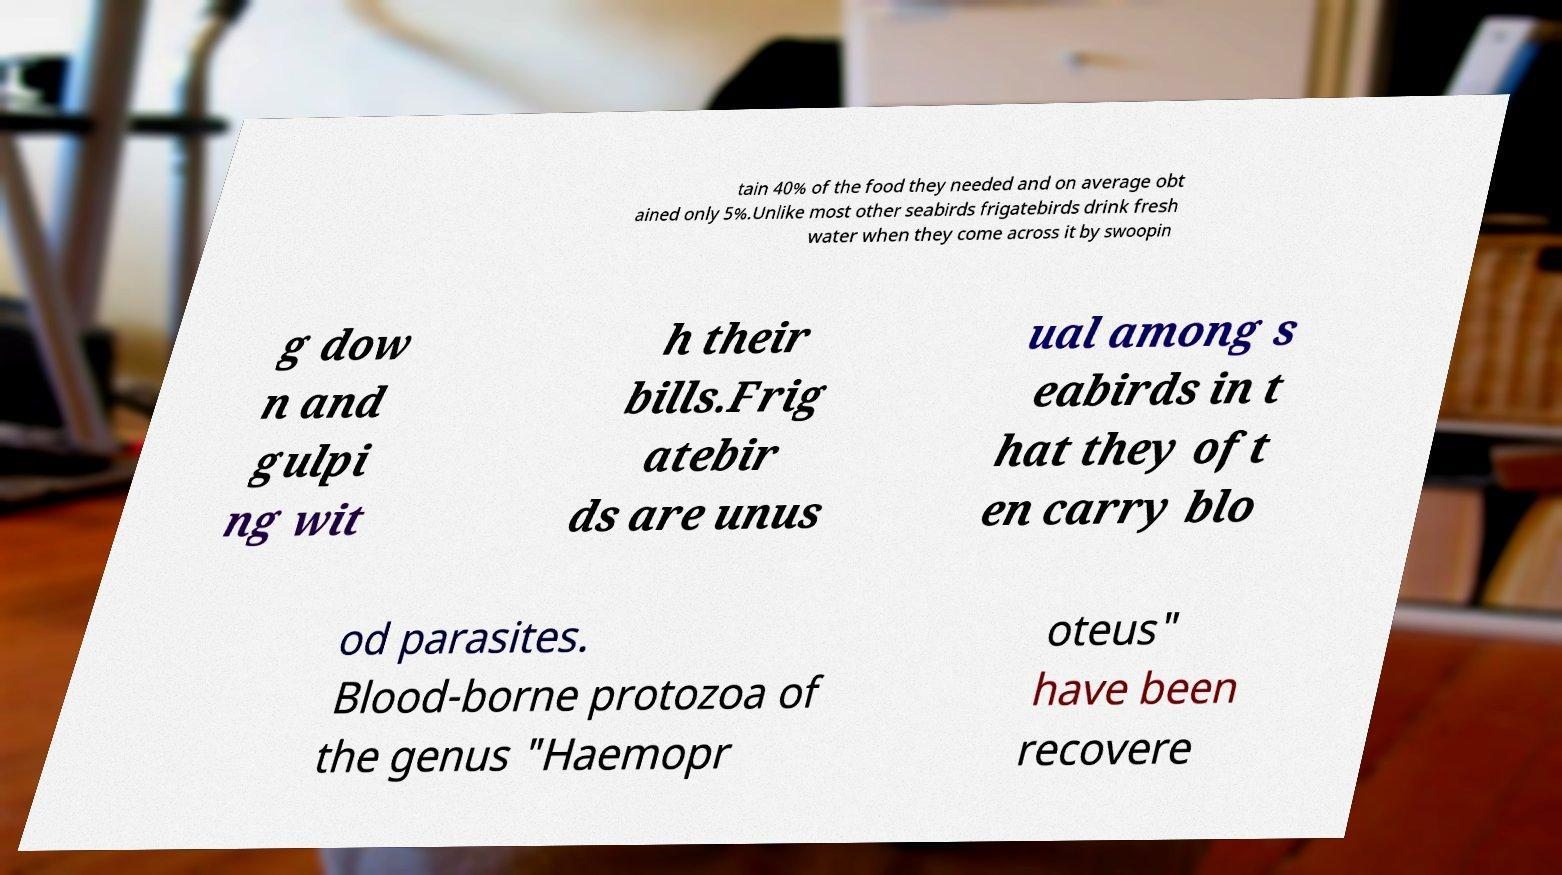What messages or text are displayed in this image? I need them in a readable, typed format. tain 40% of the food they needed and on average obt ained only 5%.Unlike most other seabirds frigatebirds drink fresh water when they come across it by swoopin g dow n and gulpi ng wit h their bills.Frig atebir ds are unus ual among s eabirds in t hat they oft en carry blo od parasites. Blood-borne protozoa of the genus "Haemopr oteus" have been recovere 